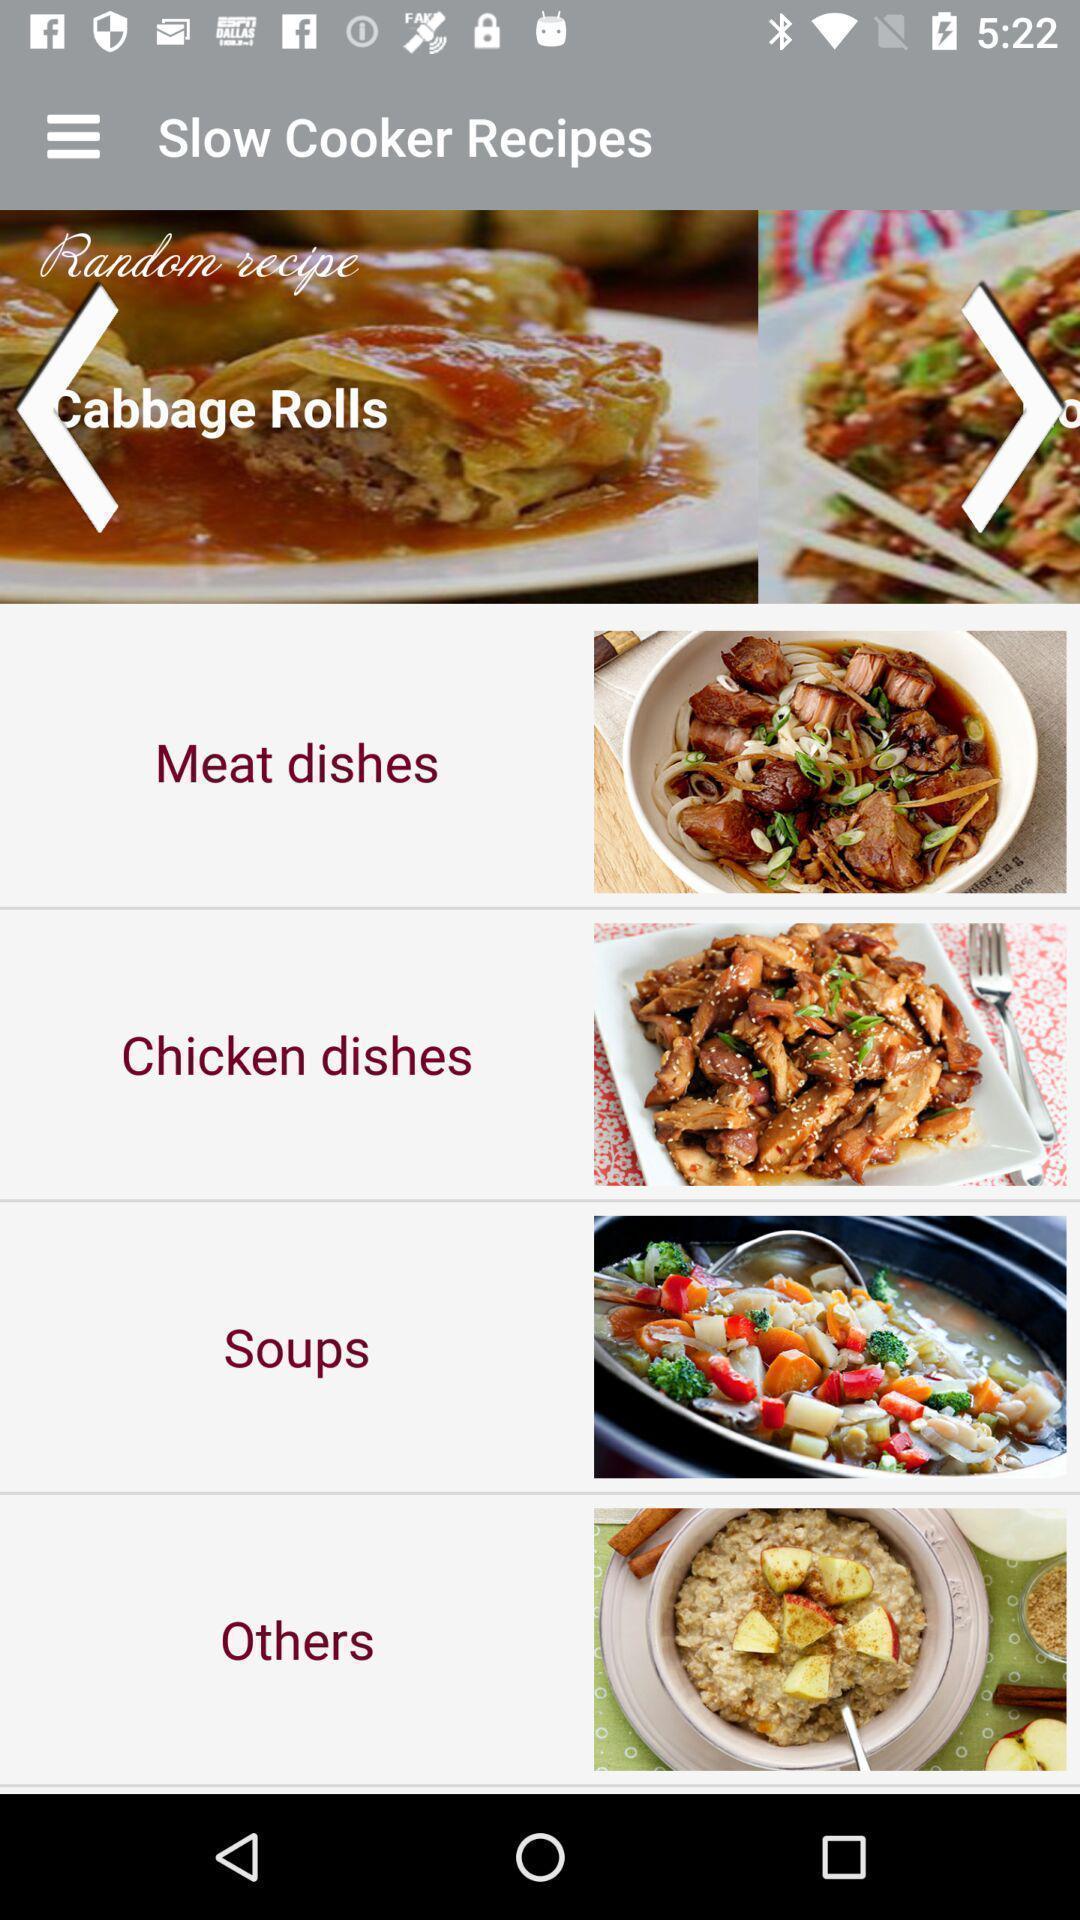What is the overall content of this screenshot? Page displaying slow cooking recipes of a cooking app. 